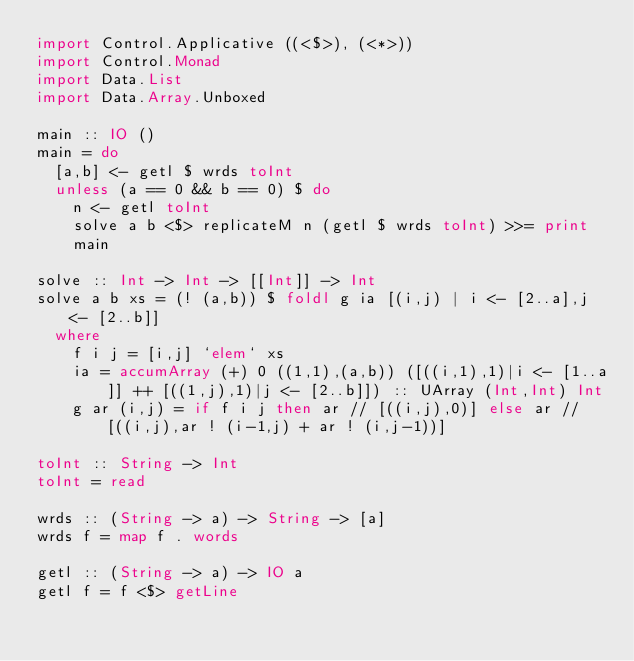<code> <loc_0><loc_0><loc_500><loc_500><_Haskell_>import Control.Applicative ((<$>), (<*>))
import Control.Monad
import Data.List
import Data.Array.Unboxed

main :: IO ()
main = do
  [a,b] <- getl $ wrds toInt
  unless (a == 0 && b == 0) $ do
    n <- getl toInt
    solve a b <$> replicateM n (getl $ wrds toInt) >>= print
    main

solve :: Int -> Int -> [[Int]] -> Int
solve a b xs = (! (a,b)) $ foldl g ia [(i,j) | i <- [2..a],j <- [2..b]]
  where
    f i j = [i,j] `elem` xs
    ia = accumArray (+) 0 ((1,1),(a,b)) ([((i,1),1)|i <- [1..a]] ++ [((1,j),1)|j <- [2..b]]) :: UArray (Int,Int) Int
    g ar (i,j) = if f i j then ar // [((i,j),0)] else ar // [((i,j),ar ! (i-1,j) + ar ! (i,j-1))]

toInt :: String -> Int
toInt = read

wrds :: (String -> a) -> String -> [a]
wrds f = map f . words

getl :: (String -> a) -> IO a
getl f = f <$> getLine</code> 